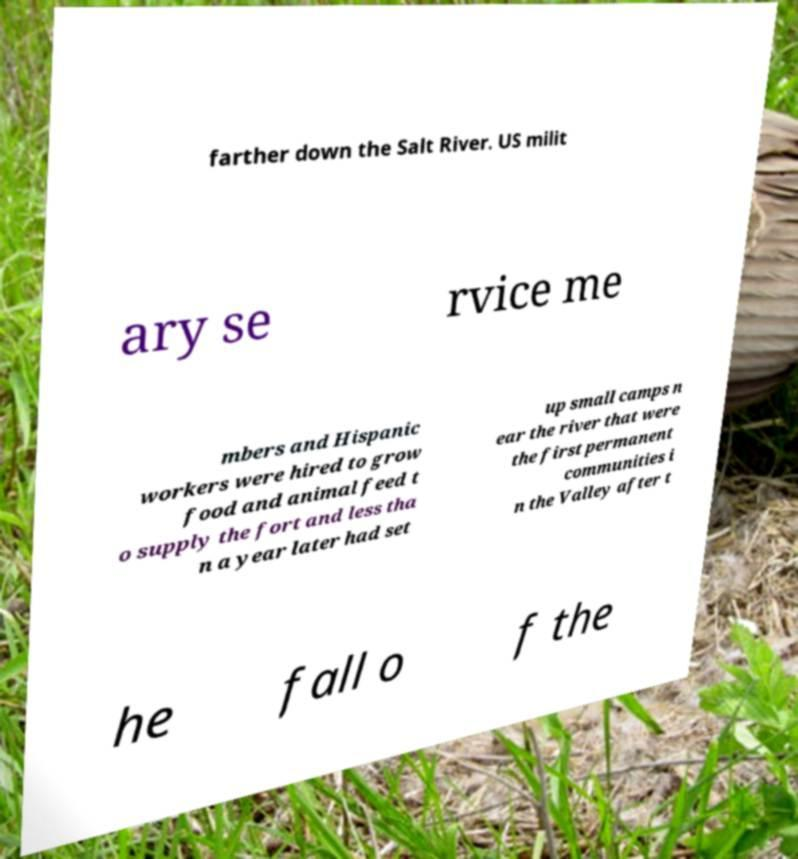Can you accurately transcribe the text from the provided image for me? farther down the Salt River. US milit ary se rvice me mbers and Hispanic workers were hired to grow food and animal feed t o supply the fort and less tha n a year later had set up small camps n ear the river that were the first permanent communities i n the Valley after t he fall o f the 